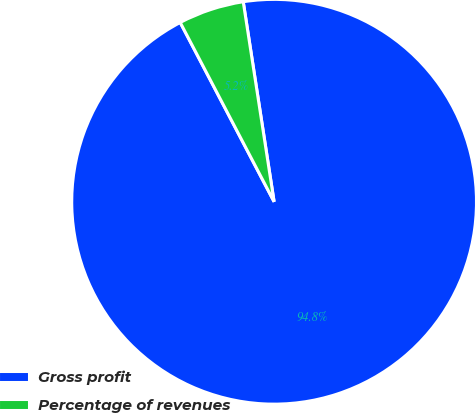Convert chart to OTSL. <chart><loc_0><loc_0><loc_500><loc_500><pie_chart><fcel>Gross profit<fcel>Percentage of revenues<nl><fcel>94.76%<fcel>5.24%<nl></chart> 